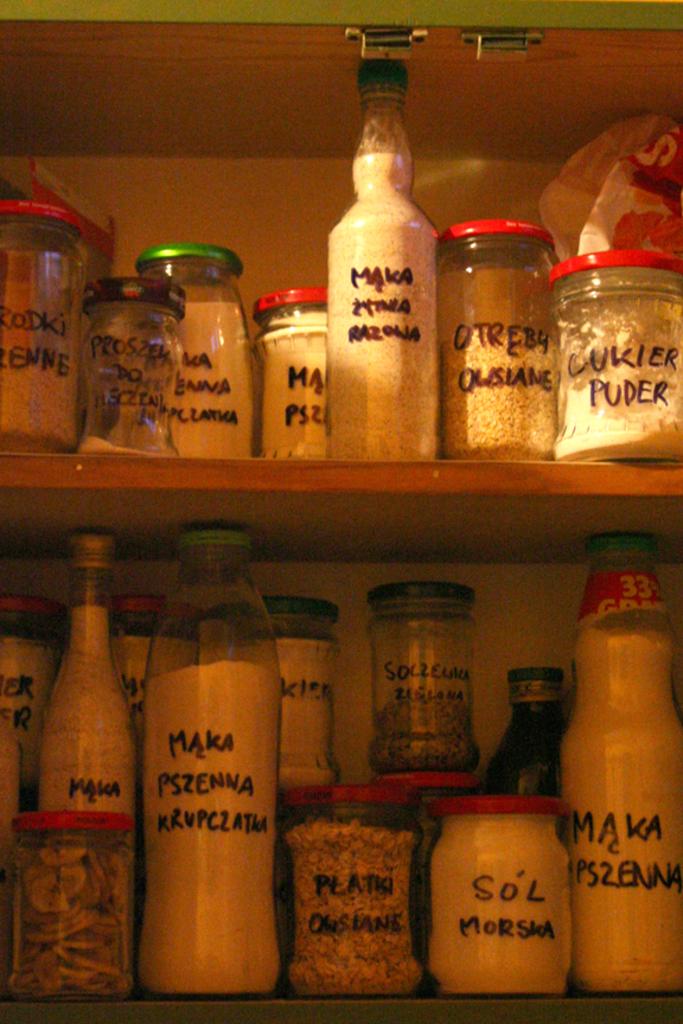What is in the top right jar?
Provide a succinct answer. Cukier puder. What is in the jar on the bottom right?
Your answer should be compact. Maka ps2enna. 